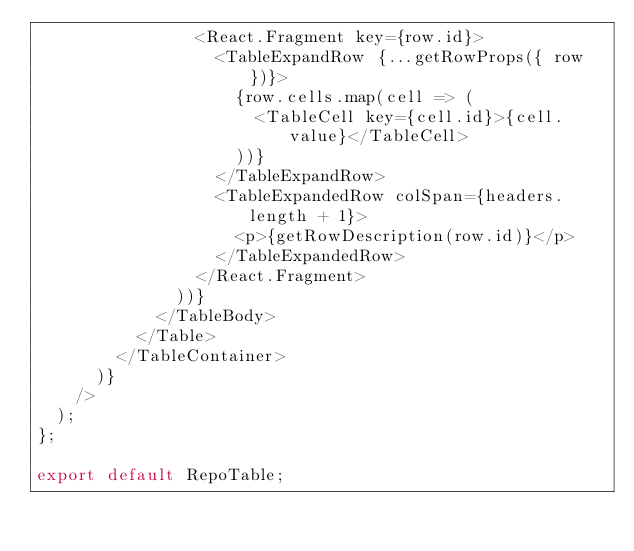<code> <loc_0><loc_0><loc_500><loc_500><_JavaScript_>                <React.Fragment key={row.id}>
                  <TableExpandRow {...getRowProps({ row })}>
                    {row.cells.map(cell => (
                      <TableCell key={cell.id}>{cell.value}</TableCell>
                    ))}
                  </TableExpandRow>
                  <TableExpandedRow colSpan={headers.length + 1}>
                    <p>{getRowDescription(row.id)}</p>
                  </TableExpandedRow>
                </React.Fragment>
              ))}
            </TableBody>
          </Table>
        </TableContainer>
      )}
    />
  );
};

export default RepoTable;
</code> 